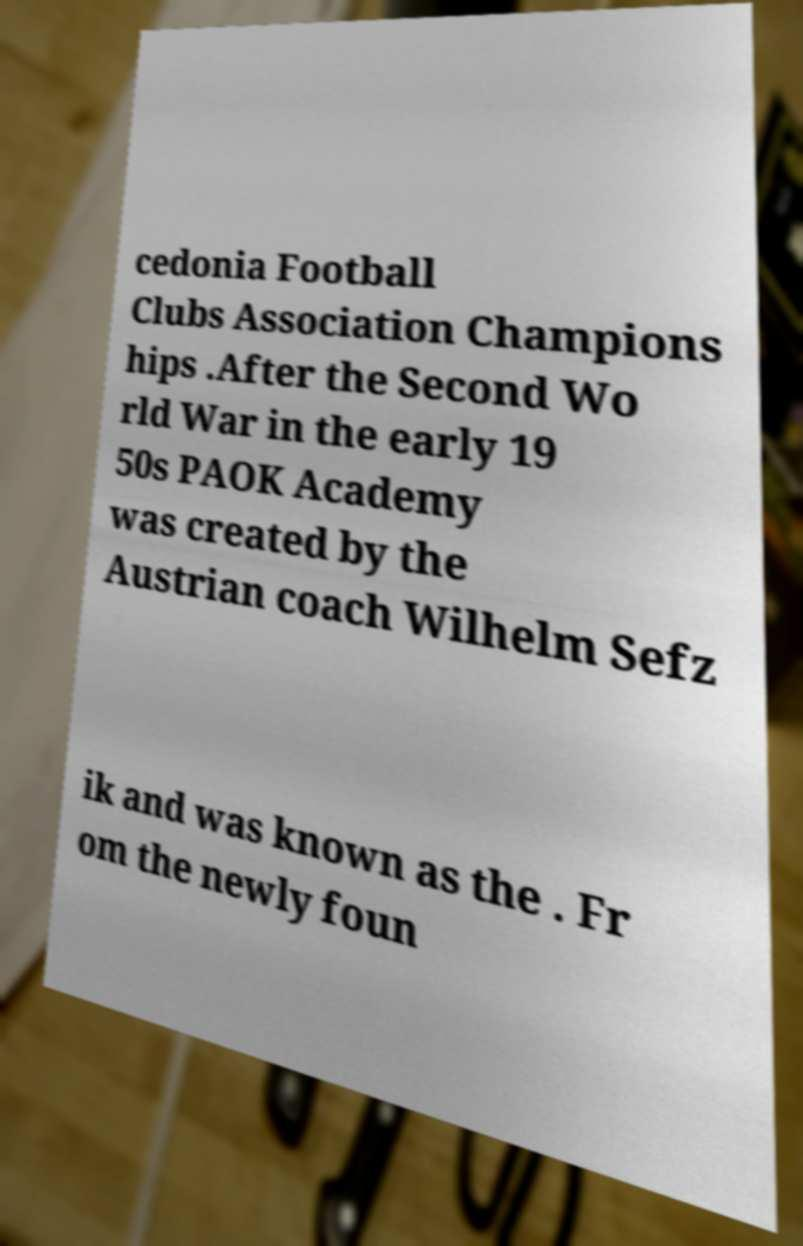There's text embedded in this image that I need extracted. Can you transcribe it verbatim? cedonia Football Clubs Association Champions hips .After the Second Wo rld War in the early 19 50s PAOK Academy was created by the Austrian coach Wilhelm Sefz ik and was known as the . Fr om the newly foun 